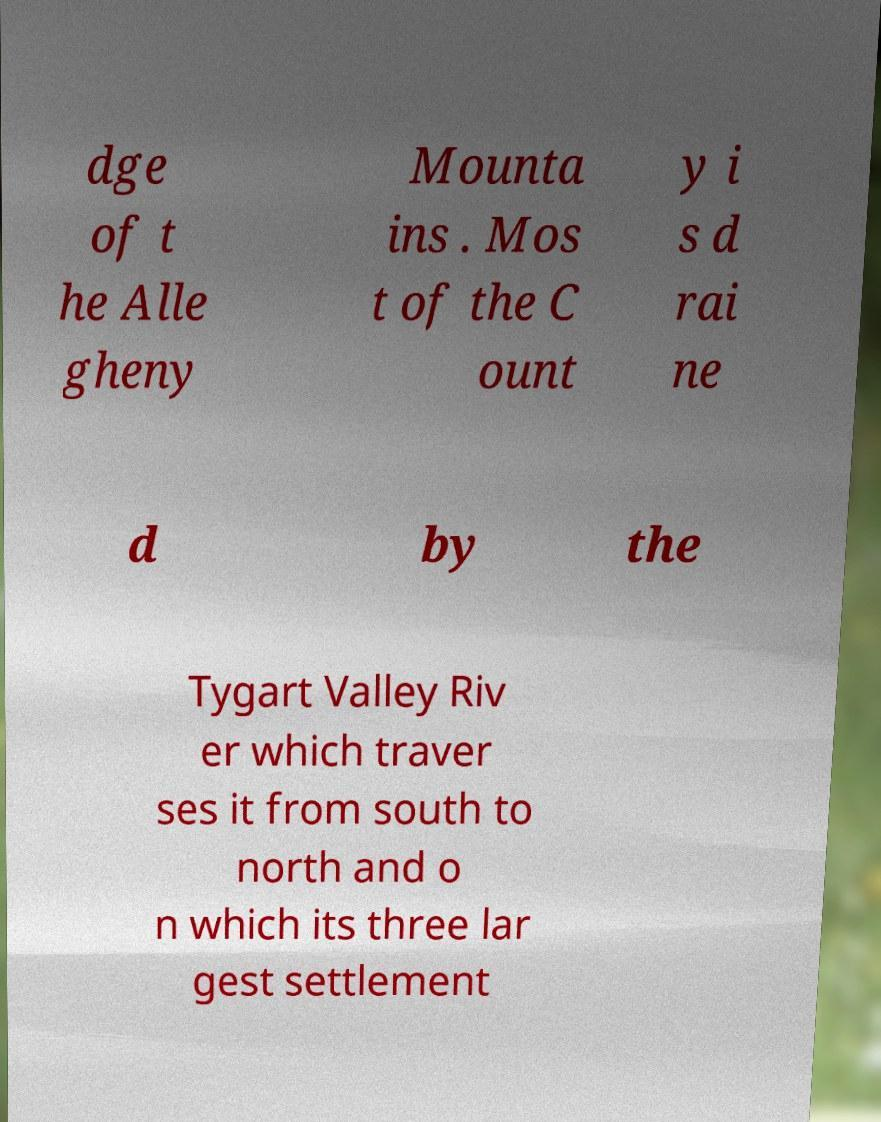Can you read and provide the text displayed in the image?This photo seems to have some interesting text. Can you extract and type it out for me? dge of t he Alle gheny Mounta ins . Mos t of the C ount y i s d rai ne d by the Tygart Valley Riv er which traver ses it from south to north and o n which its three lar gest settlement 